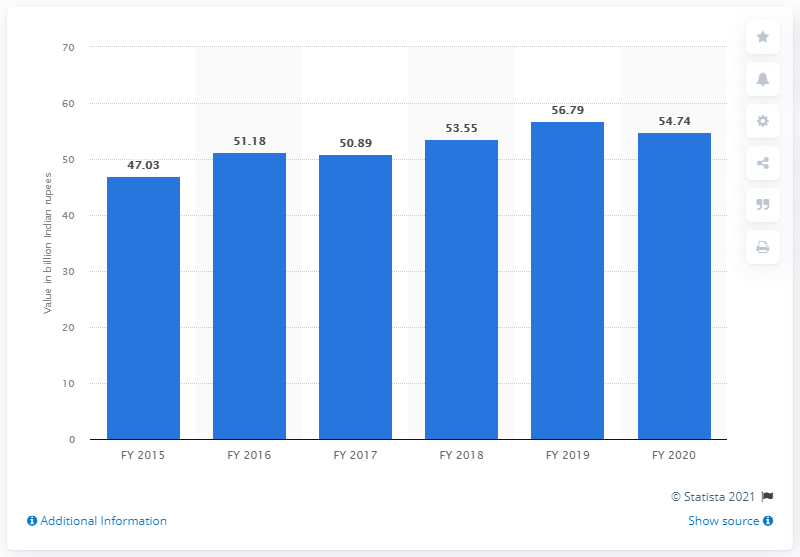Specify some key components in this picture. The turnover of Godrej Consumer Products at the end of financial year 2020 was 54.74. 